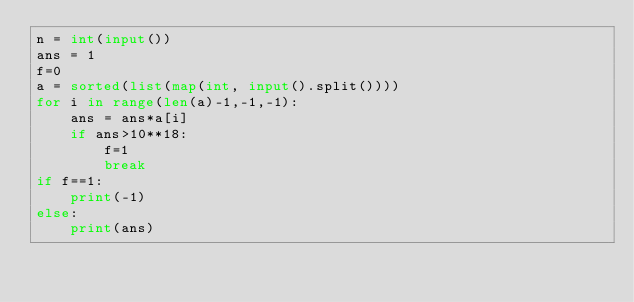<code> <loc_0><loc_0><loc_500><loc_500><_Python_>n = int(input())
ans = 1
f=0
a = sorted(list(map(int, input().split())))
for i in range(len(a)-1,-1,-1):
    ans = ans*a[i]
    if ans>10**18:
        f=1
        break
if f==1:
    print(-1)
else:
    print(ans)</code> 